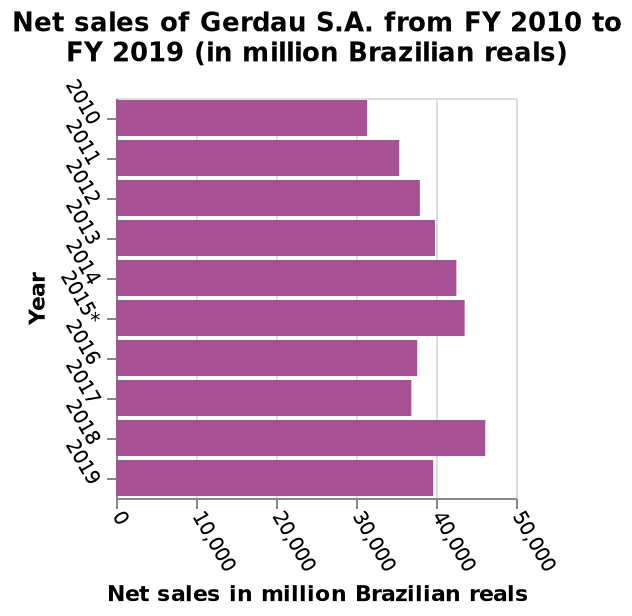<image>
What does the x-axis represent in the bar plot? The x-axis in the bar plot represents the net sales in million Brazilian reals. Did sales in 2019 increase or decrease compared to 2017? Sales in 2019 had a slight decline compared to 2017, but still remained higher. 